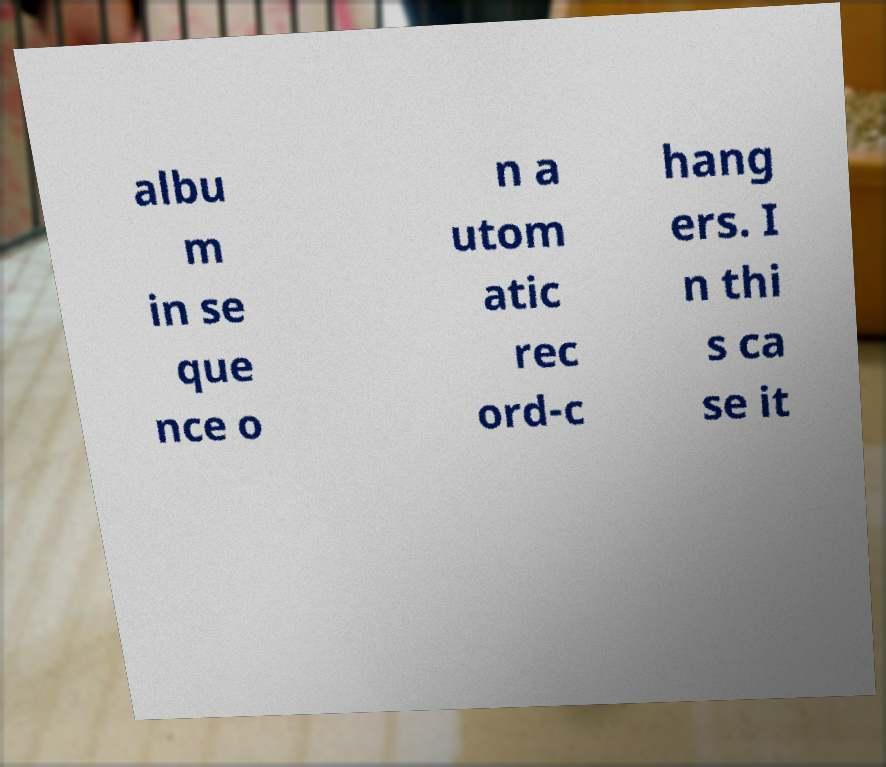For documentation purposes, I need the text within this image transcribed. Could you provide that? albu m in se que nce o n a utom atic rec ord-c hang ers. I n thi s ca se it 